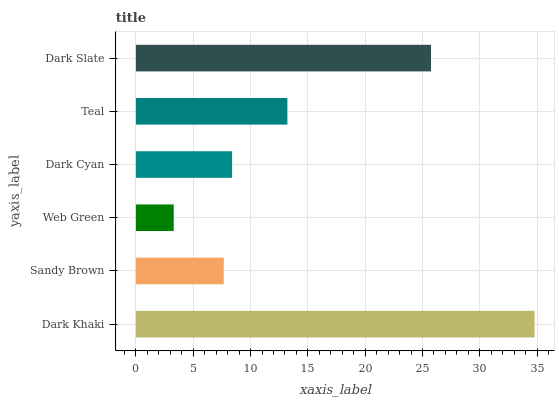Is Web Green the minimum?
Answer yes or no. Yes. Is Dark Khaki the maximum?
Answer yes or no. Yes. Is Sandy Brown the minimum?
Answer yes or no. No. Is Sandy Brown the maximum?
Answer yes or no. No. Is Dark Khaki greater than Sandy Brown?
Answer yes or no. Yes. Is Sandy Brown less than Dark Khaki?
Answer yes or no. Yes. Is Sandy Brown greater than Dark Khaki?
Answer yes or no. No. Is Dark Khaki less than Sandy Brown?
Answer yes or no. No. Is Teal the high median?
Answer yes or no. Yes. Is Dark Cyan the low median?
Answer yes or no. Yes. Is Web Green the high median?
Answer yes or no. No. Is Web Green the low median?
Answer yes or no. No. 